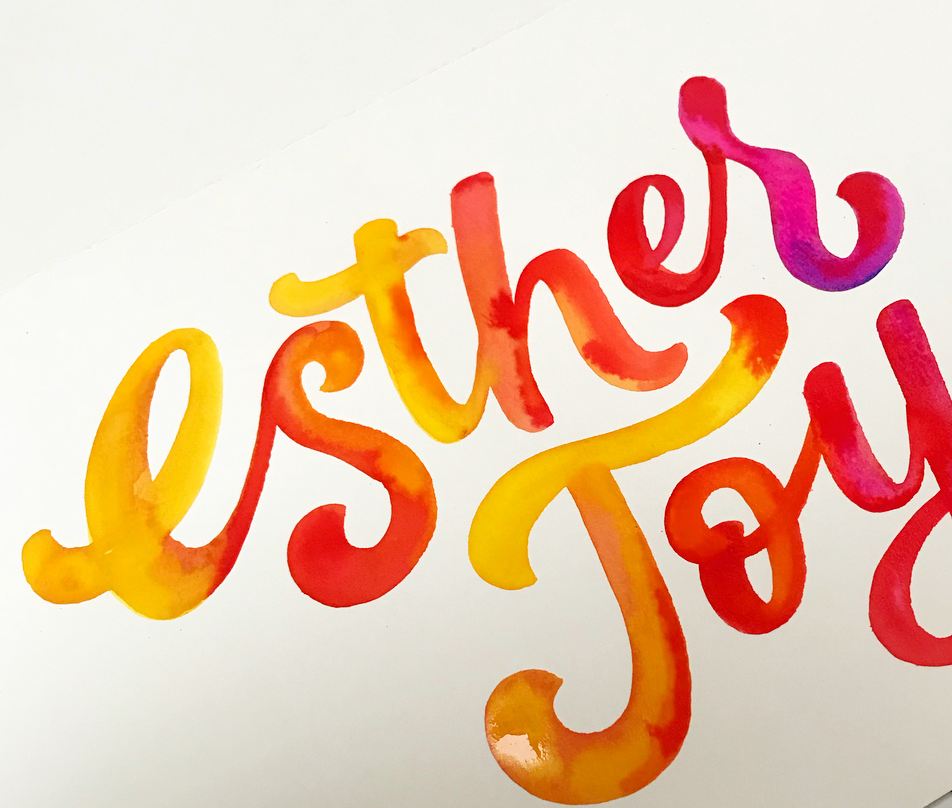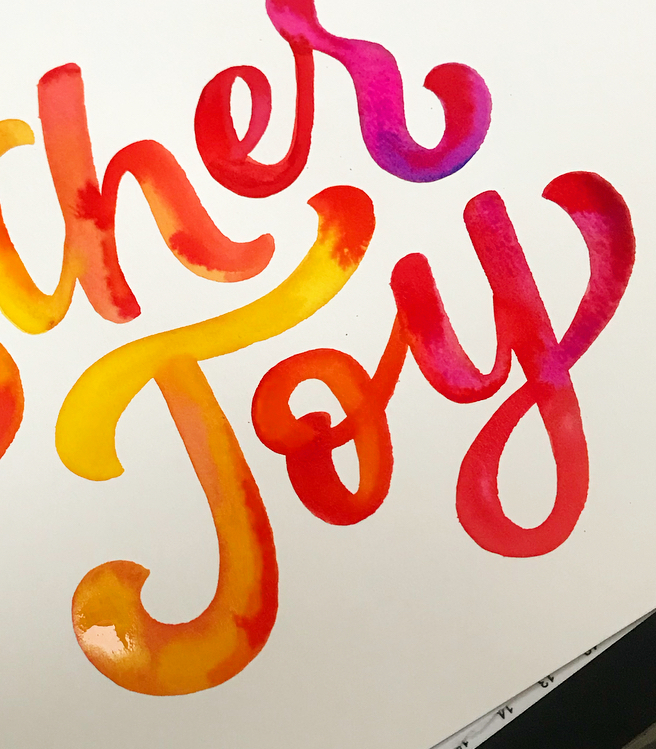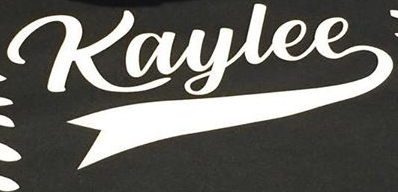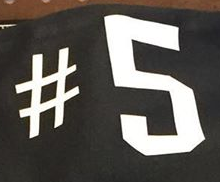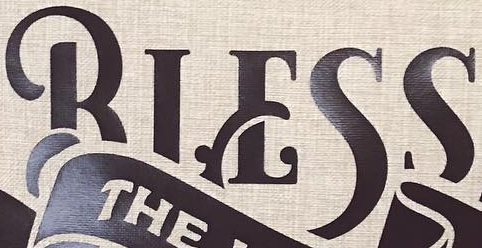Read the text from these images in sequence, separated by a semicolon. Esthes; Joy; Kaylee; #5; BIESS 